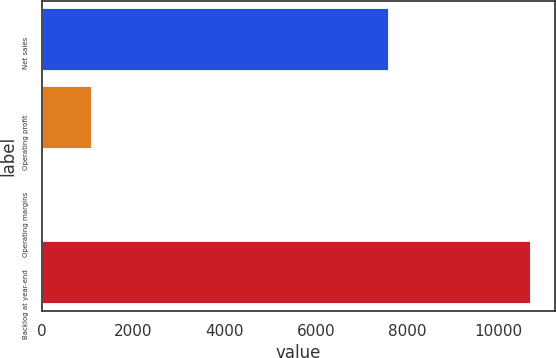Convert chart. <chart><loc_0><loc_0><loc_500><loc_500><bar_chart><fcel>Net sales<fcel>Operating profit<fcel>Operating margins<fcel>Backlog at year-end<nl><fcel>7579<fcel>1078.73<fcel>9.7<fcel>10700<nl></chart> 